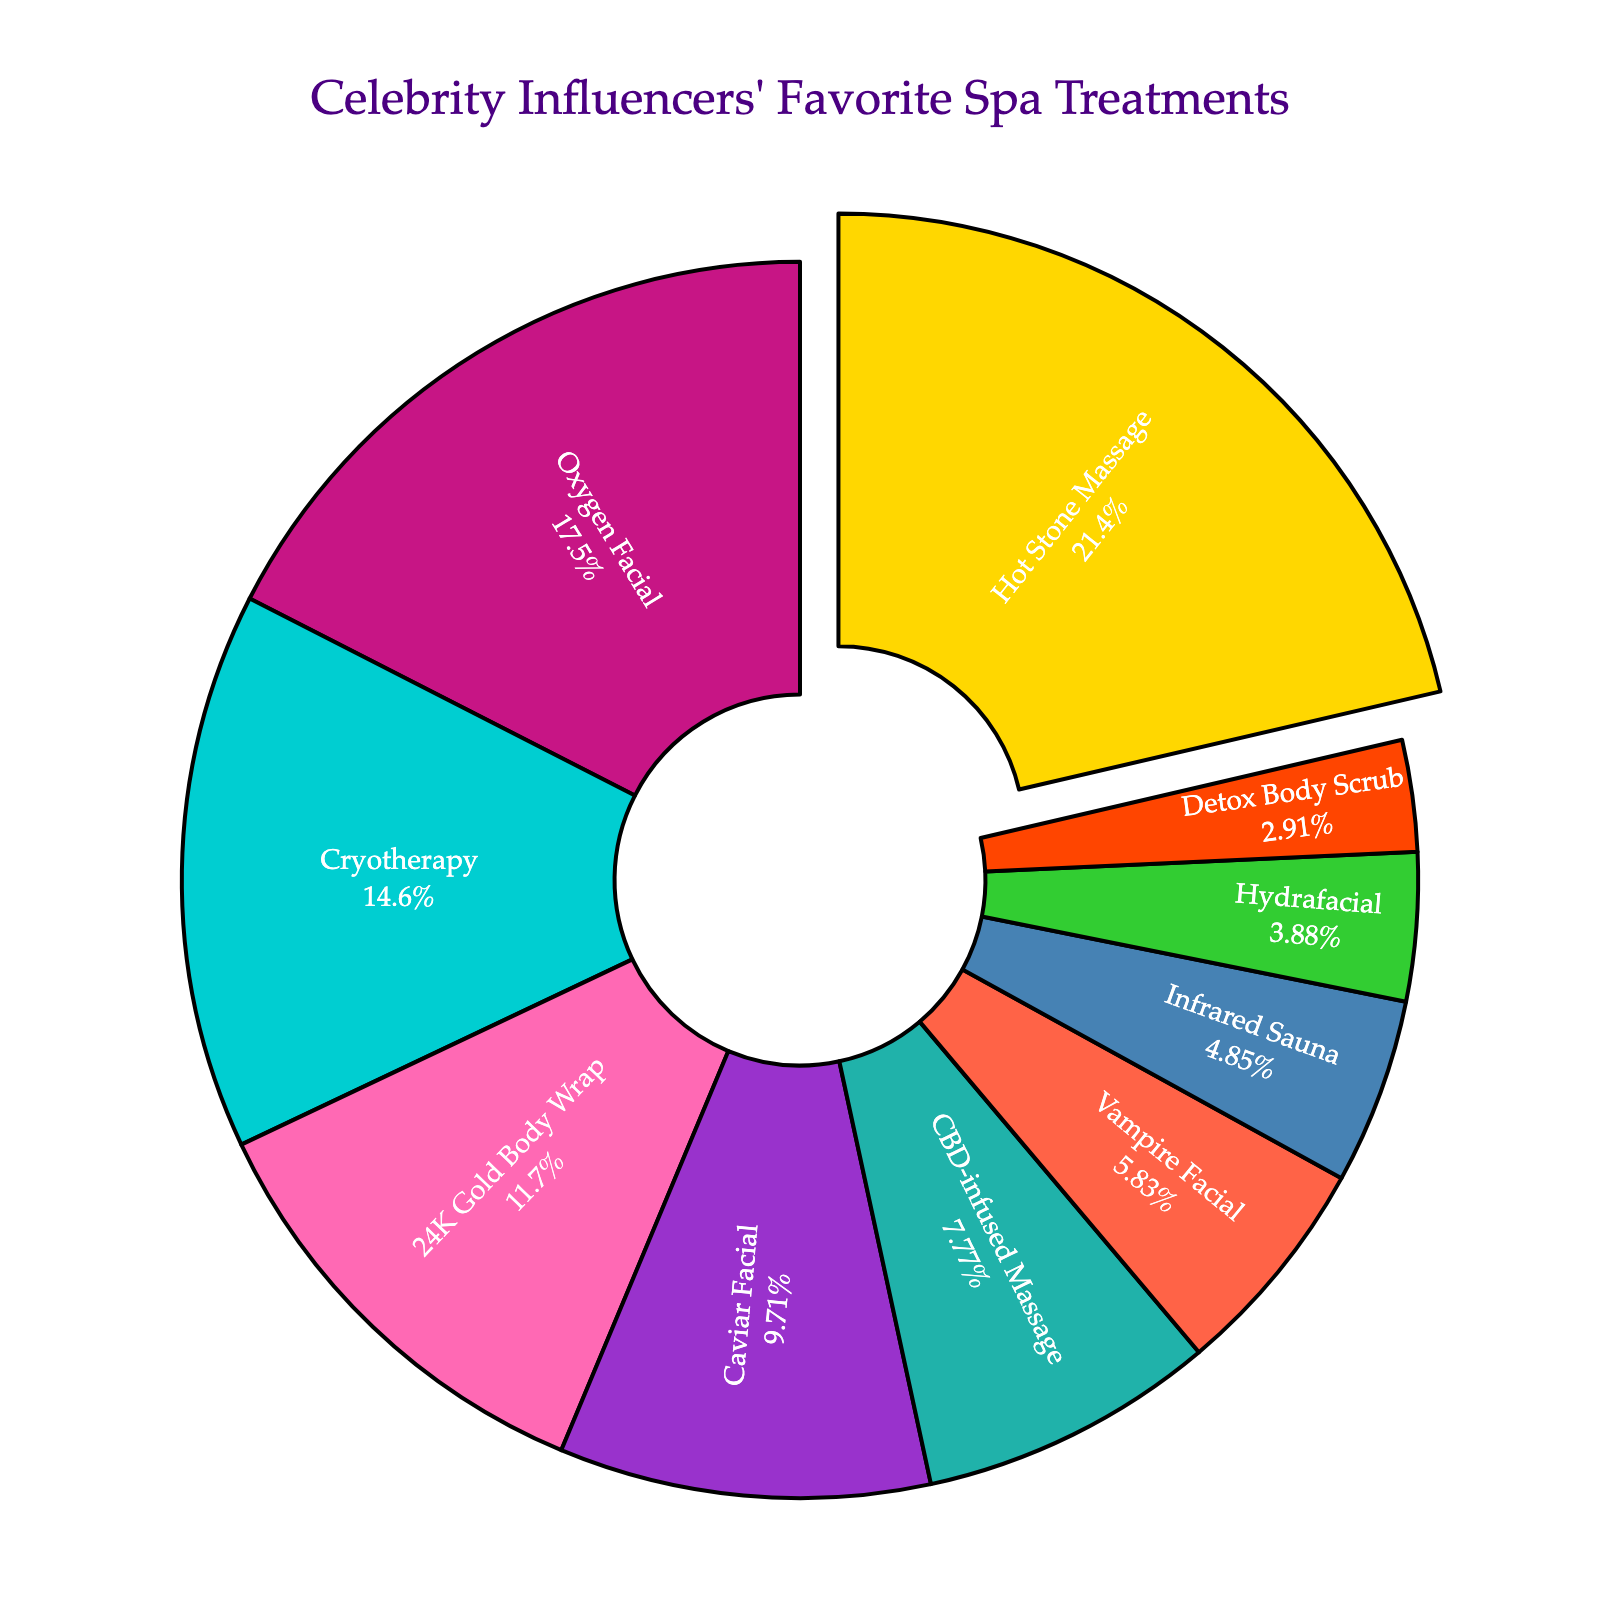Which spa treatment is the most popular among celebrity influencers? To find the most popular spa treatment, look for the segment with the largest percentage. The Hot Stone Massage has the largest segment, indicating its popularity.
Answer: Hot Stone Massage What percentage of celebrity influencers prefer 24K Gold Body Wraps? Find the segment in the pie chart corresponding to the 24K Gold Body Wrap, and refer to the percentage inside it.
Answer: 12% How much more popular is the Hot Stone Massage compared to the Infrared Sauna? First find the percentage of both treatments: Hot Stone Massage is 22%, and Infrared Sauna is 5%. Subtract the percentage of the Infrared Sauna from the Hot Stone Massage: 22% - 5% = 17%.
Answer: 17% Which treatment is less popular, Detox Body Scrub or Vampire Facial, and by how much? Find the percentages for both treatments: Vampire Facial (6%) and Detox Body Scrub (3%). Subtract the percentage of Detox Body Scrub from Vampire Facial: 6% - 3% = 3%.
Answer: Detox Body Scrub by 3% What is the total percentage of influencers who prefer either Caviar Facial or CBD-infused Massage? Add the percentages for Caviar Facial and CBD-infused Massage: 10% + 8% = 18%.
Answer: 18% Between the Oxygen Facial and Hydrafacial, which one is more popular and by what percentage? Find the percentages: Oxygen Facial is 18% and Hydrafacial is 4%. Subtract the percentage of Hydrafacial from Oxygen Facial: 18% - 4% = 14%.
Answer: Oxygen Facial by 14% Which treatments have a combined popularity greater than Cryotherapy? Cryotherapy has 15%. Add percentages of smaller treatments until their sum exceeds 15%. Caviar Facial (10%) + CBD-infused Massage (8%) = 18%. Note that Detox Body Scrub and Hydrafacial combined (3% + 4%) = 7%, which is not greater than 15%. Thus the valid combination is only Caviar Facial and CBD-infused Massage.
Answer: Caviar Facial and CBD-infused Massage What is the average percentage of popularity among the three least popular treatments? Identify the three least popular treatments and their percentages: Detox Body Scrub (3%), Hydrafacial (4%), and Infrared Sauna (5%). Calculate their average: (3% + 4% + 5%) / 3 = 12% / 3 = 4%.
Answer: 4% Which treatments have less than 10% popularity combined? Identify all treatments with less than 10% individually and sum their percentages. Vampire Facial (6%), Infrared Sauna (5%), Hydrafacial (4%), and Detox Body Scrub (3%). Add them up: 6% + 5% + 4% + 3% = 18%.
Answer: Vampire Facial, Infrared Sauna, Hydrafacial, Detox Body Scrub What is the difference in popularity between the top two treatments? Identify the top two treatments: Hot Stone Massage (22%) and Oxygen Facial (18%). Subtract the percentage of Oxygen Facial from Hot Stone Massage: 22% - 18% = 4%.
Answer: 4% 